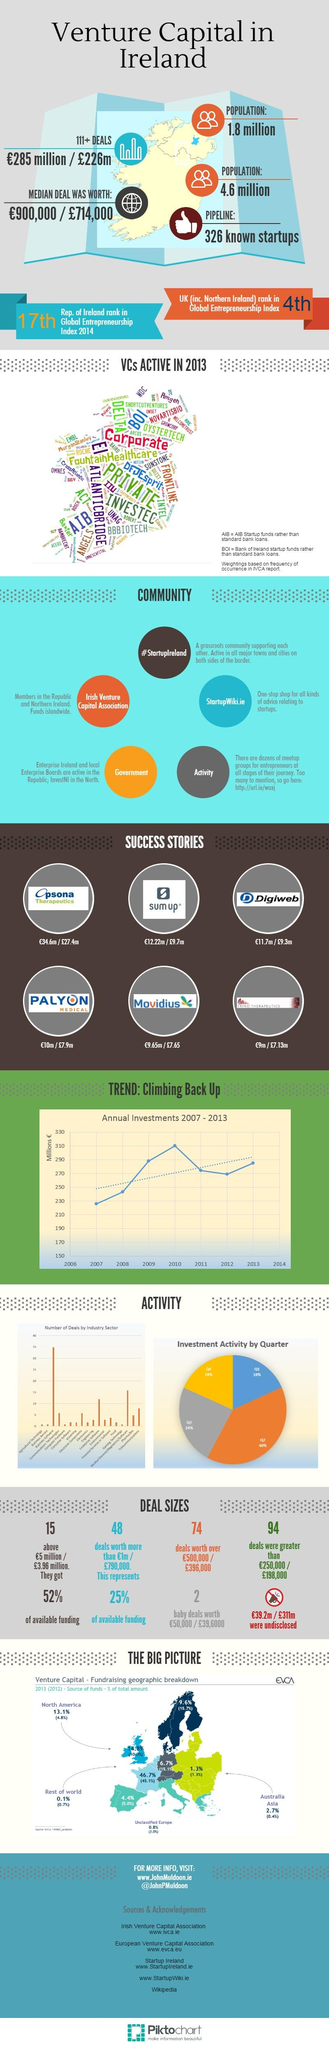Draw attention to some important aspects in this diagram. In 2013, only 2.7% of the total amount received in Australia was funded by venture capital. There have been 74 venture capital deals in which the amount invested was over €500,000 or €396,000, respectively. In 2012, only 4.8% of the total amount of funding in North America was provided by venture capital. The venture capital made a total of 94 deals that were greater than €250,000 or €396,000. 